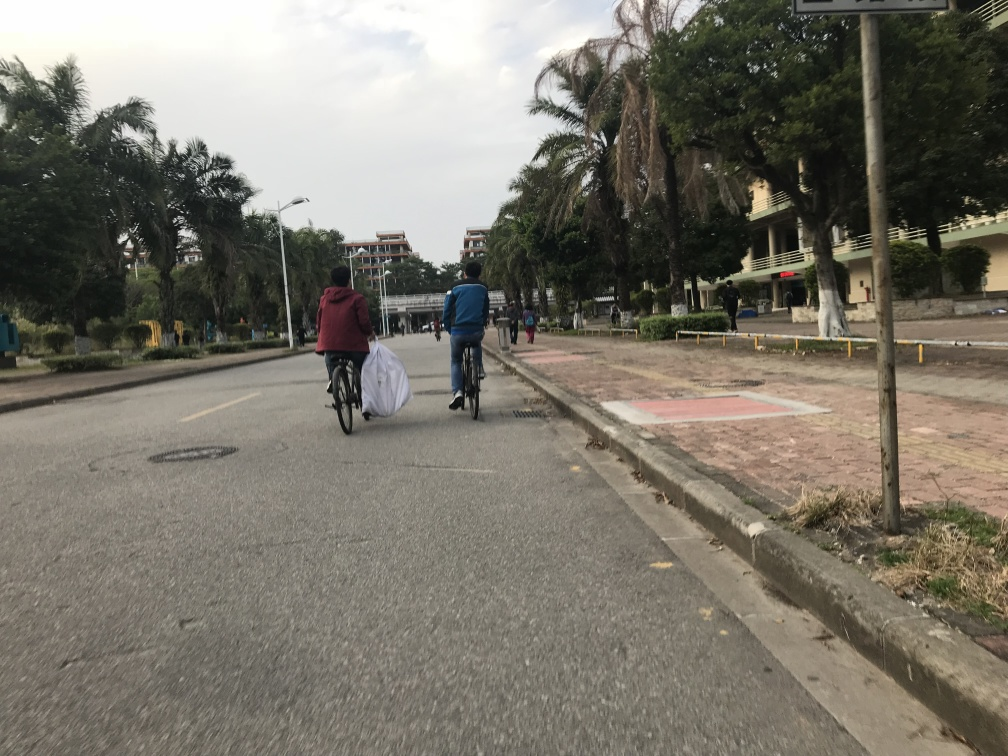Can you describe the weather and time of day this photo appears to have been taken? The photo seems to have been captured during the daytime, judging by the natural light, although the exact time cannot be determined. The sky appears to be overcast with no visible shadows, which suggests it could be either morning or afternoon under cloudy conditions. The lack of sharp shadows suggests that either the sun is obscured by clouds or it is not at its peak position, suggesting it's not midday.  What can you infer about the lifestyle or habits of the individuals in the photo? The individuals in the photo are riding bicycles, which may indicate a preference for cycling as a mode of transportation or for physical exercise. The casual attire and backpacks suggest a utilitarian use of the bicycles, potentially for commuting. The presence of the sidewalk and the dedicated bicycle lane implies that the area is equipped for cyclists and pedestrians, indicating that active transportation is supported in this location. 